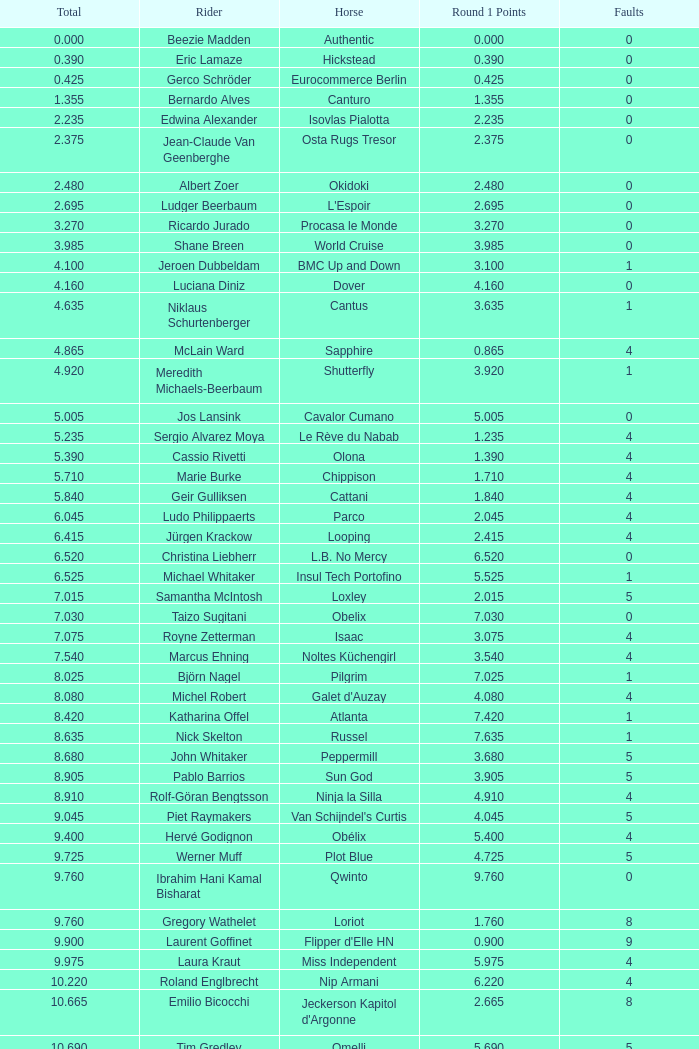Tell me the most total for horse of carlson 29.545. 